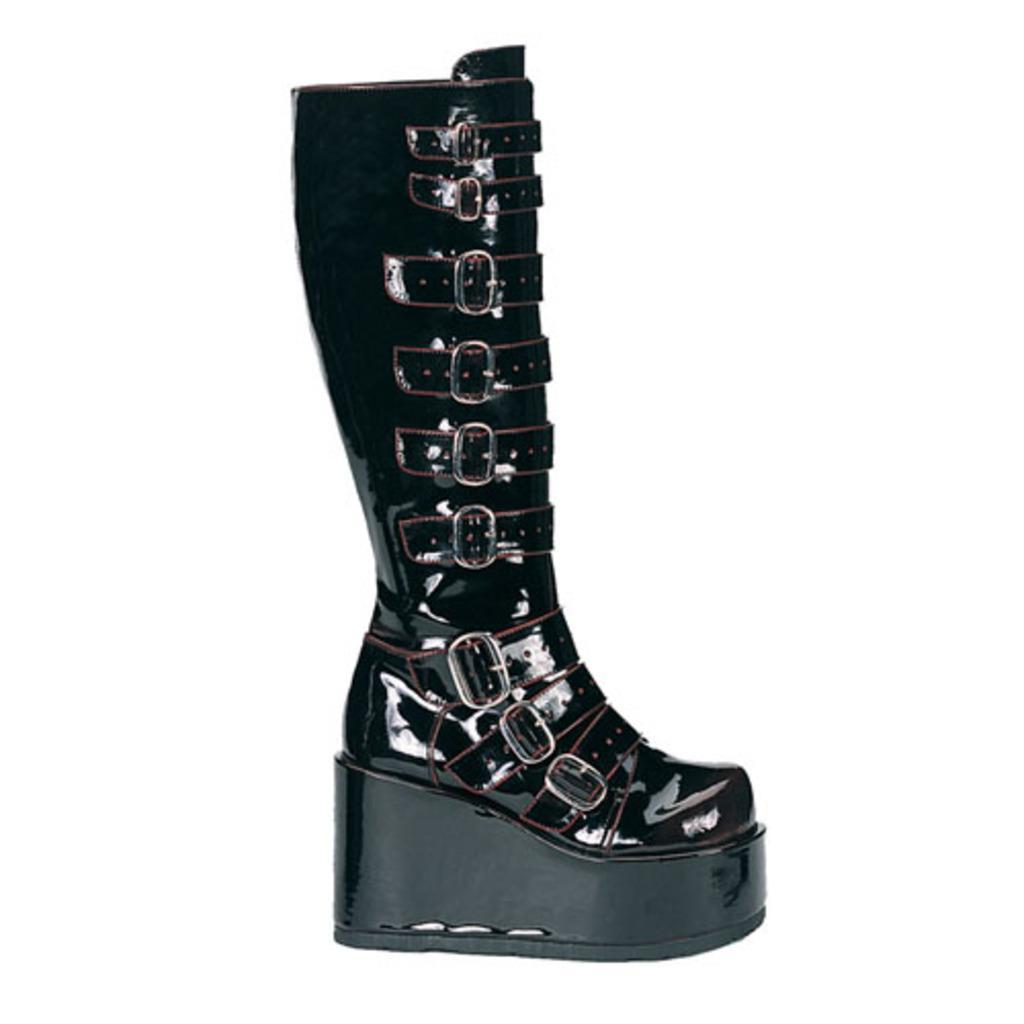Could you give a brief overview of what you see in this image? There is a black color boot with buckles. In the background it is white. 